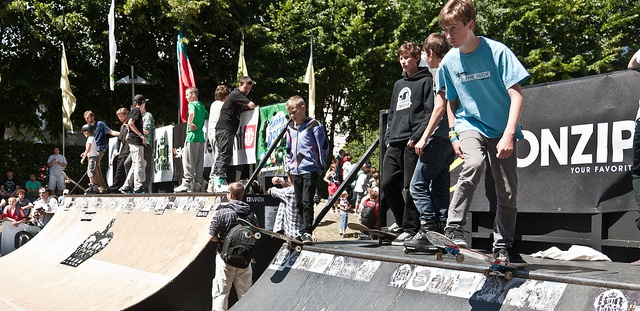Describe the objects in this image and their specific colors. I can see people in black, lightgray, blue, and gray tones, people in black, white, gray, and darkgray tones, people in black, gray, white, and maroon tones, people in black, gray, lightgray, and darkgray tones, and people in black, gray, white, and darkgray tones in this image. 